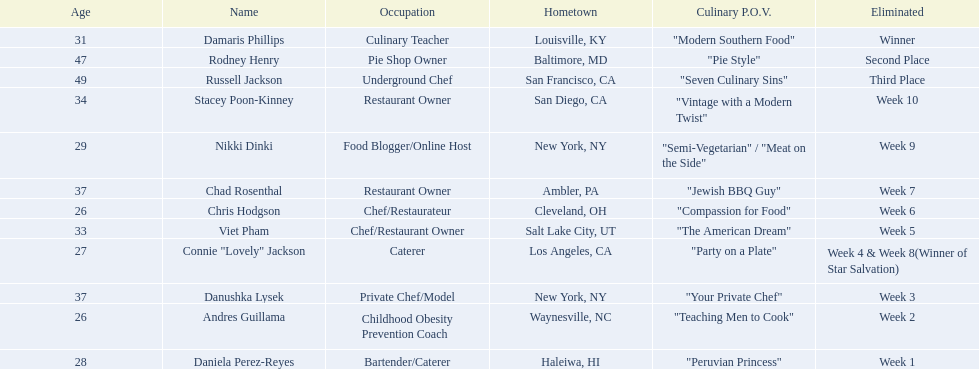Which food network star contestants are in their 20s? Nikki Dinki, Chris Hodgson, Connie "Lovely" Jackson, Andres Guillama, Daniela Perez-Reyes. Of these contestants, which one is the same age as chris hodgson? Andres Guillama. 